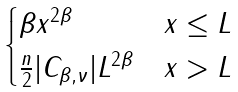<formula> <loc_0><loc_0><loc_500><loc_500>\begin{cases} \beta x ^ { 2 \beta } & x \leq L \\ \frac { n } { 2 } | C _ { \beta , \nu } | L ^ { 2 \beta } & x > L \end{cases}</formula> 